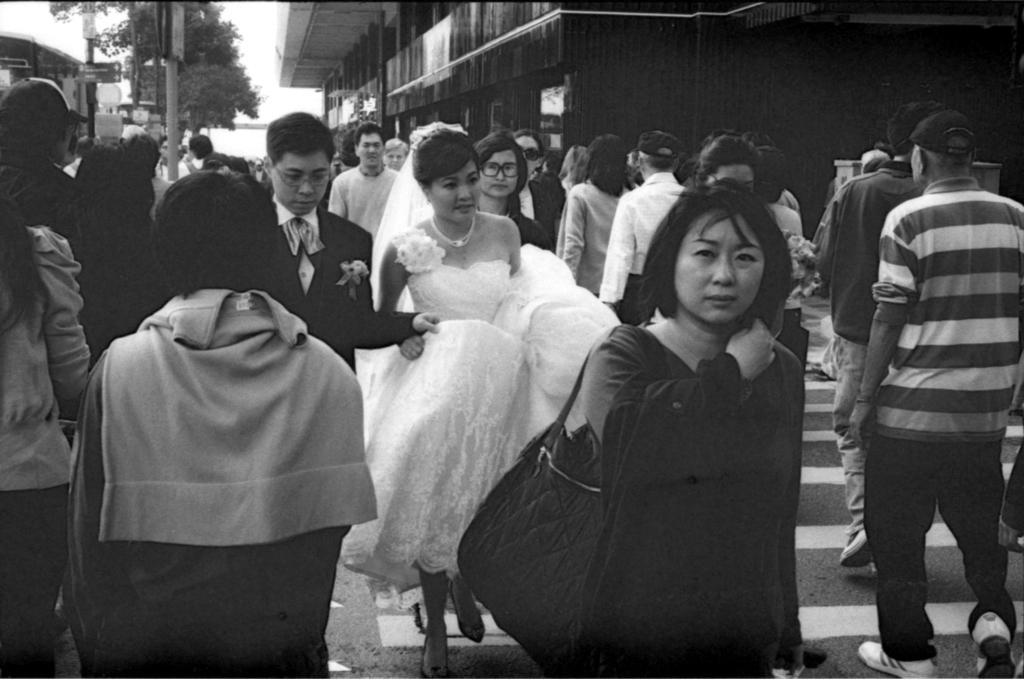What is the color scheme of the image? The image is black and white. What can be seen happening on the road in the image? There are people walking on the road in the image. What is visible in the background of the image? There are buildings, trees, poles, and the sky visible in the background of the image. Can you tell me what book the person is reading while swimming in the image? There is no person reading a book while swimming in the image, as the image does not depict any swimming or books. 